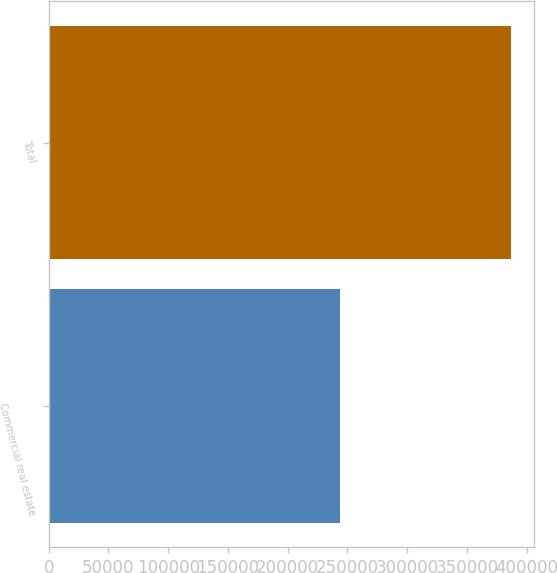Convert chart. <chart><loc_0><loc_0><loc_500><loc_500><bar_chart><fcel>Commercial real estate<fcel>Total<nl><fcel>243652<fcel>386652<nl></chart> 